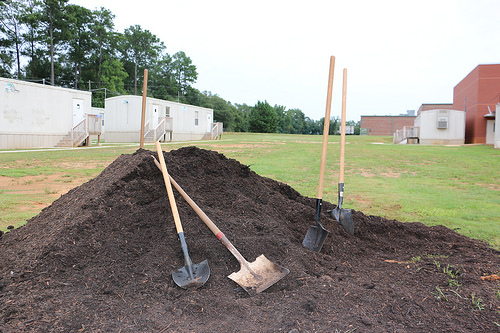<image>
Is there a shovel in the dirt? Yes. The shovel is contained within or inside the dirt, showing a containment relationship. 